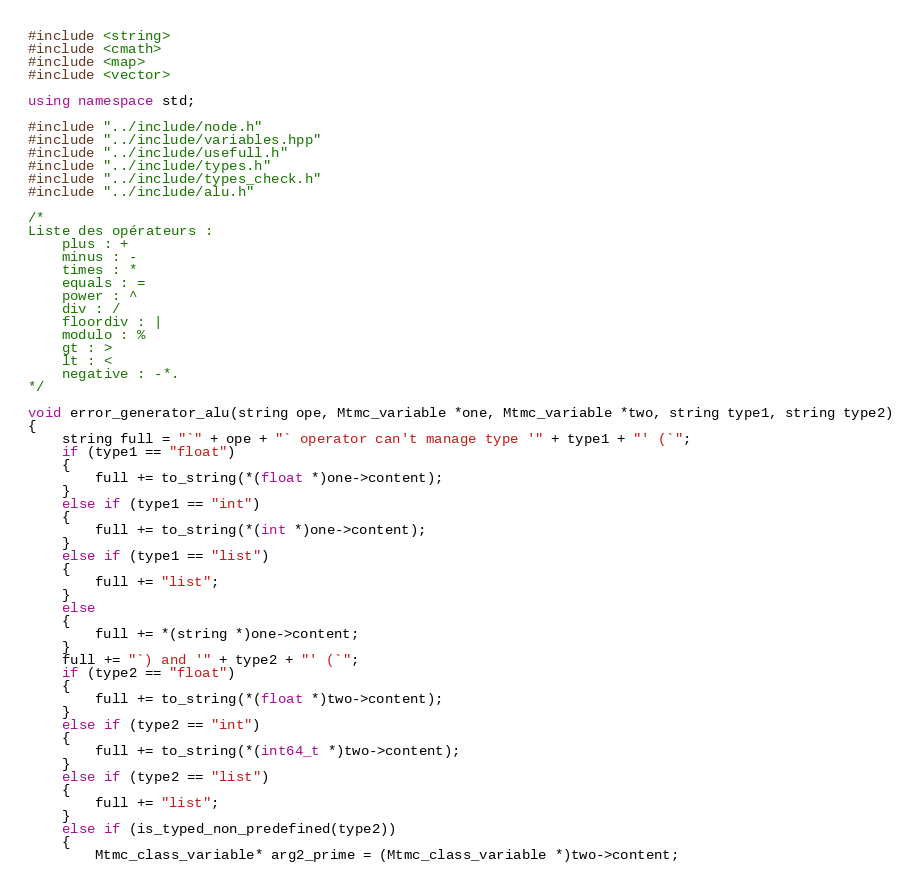Convert code to text. <code><loc_0><loc_0><loc_500><loc_500><_C++_>#include <string>
#include <cmath>
#include <map>
#include <vector>

using namespace std;

#include "../include/node.h"
#include "../include/variables.hpp"
#include "../include/usefull.h"
#include "../include/types.h"
#include "../include/types_check.h"
#include "../include/alu.h"

/*
Liste des opérateurs : 
    plus : +
    minus : -
    times : *
    equals : =
    power : ^
    div : /
    floordiv : |
    modulo : %
    gt : >
    lt : <
    negative : -*.
*/

void error_generator_alu(string ope, Mtmc_variable *one, Mtmc_variable *two, string type1, string type2)
{
    string full = "`" + ope + "` operator can't manage type '" + type1 + "' (`";
    if (type1 == "float")
    {
        full += to_string(*(float *)one->content);
    }
    else if (type1 == "int")
    {
        full += to_string(*(int *)one->content);
    }
    else if (type1 == "list")
    {
        full += "list";
    }
    else
    {
        full += *(string *)one->content;
    }
    full += "`) and '" + type2 + "' (`";
    if (type2 == "float")
    {
        full += to_string(*(float *)two->content);
    }
    else if (type2 == "int")
    {
        full += to_string(*(int64_t *)two->content);
    }
    else if (type2 == "list")
    {
        full += "list";
    }
    else if (is_typed_non_predefined(type2))
    {
        Mtmc_class_variable* arg2_prime = (Mtmc_class_variable *)two->content;</code> 